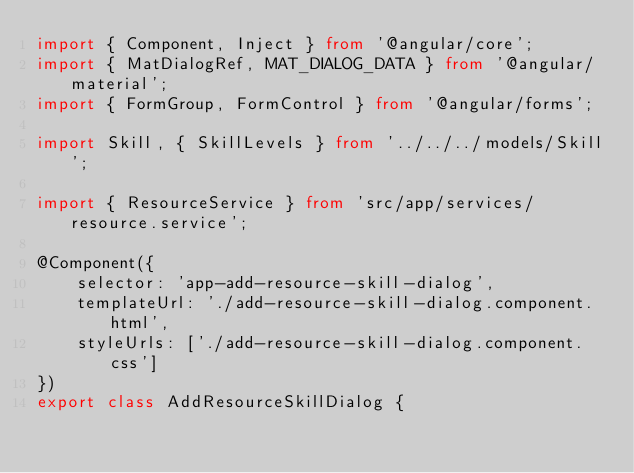Convert code to text. <code><loc_0><loc_0><loc_500><loc_500><_TypeScript_>import { Component, Inject } from '@angular/core';
import { MatDialogRef, MAT_DIALOG_DATA } from '@angular/material';
import { FormGroup, FormControl } from '@angular/forms';

import Skill, { SkillLevels } from '../../../models/Skill';

import { ResourceService } from 'src/app/services/resource.service';

@Component({
    selector: 'app-add-resource-skill-dialog',
    templateUrl: './add-resource-skill-dialog.component.html',
    styleUrls: ['./add-resource-skill-dialog.component.css']
})
export class AddResourceSkillDialog {
</code> 